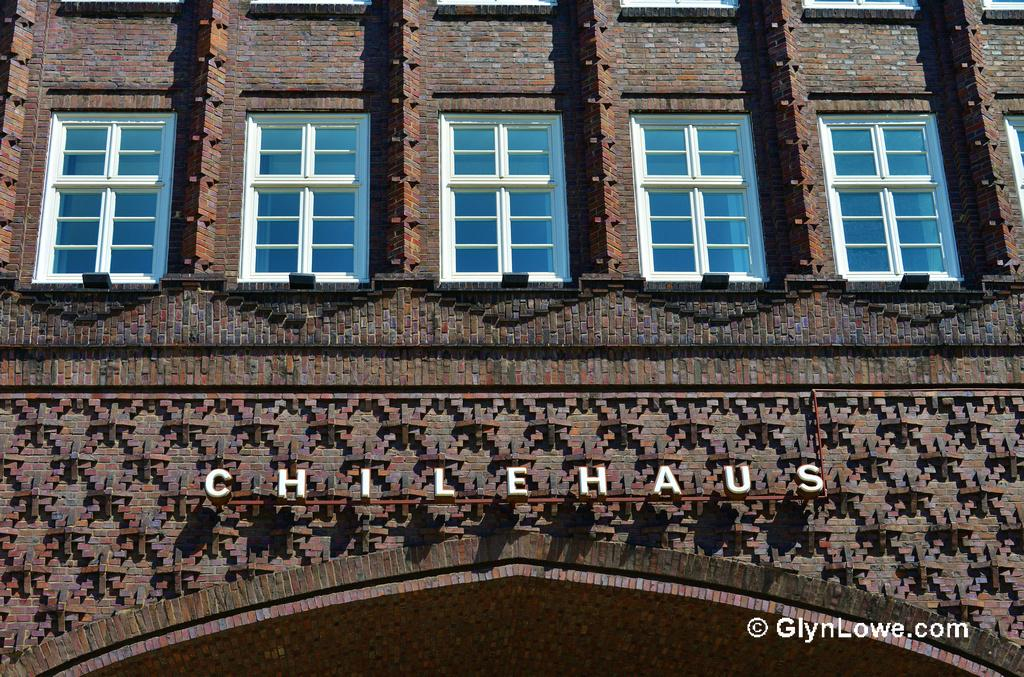What is the main subject of the picture? The main subject of the picture is a building. What features can be observed on the building? The building has windows, text, and a brick wall. How many pieces of coal can be seen in the picture? There is no coal present in the picture; the image features a building with windows, text, and a brick wall. What type of pin is holding the brick wall together in the picture? There is no pin holding the brick wall together in the picture; the wall is made of bricks that are connected without the use of pins. 